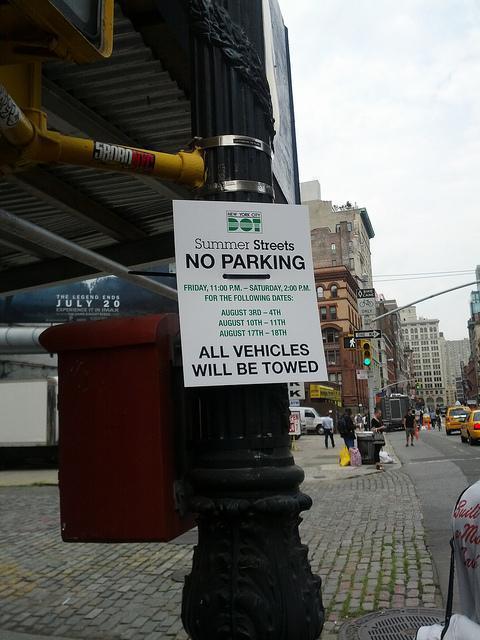What is the green on the bricks on the ground?
Pick the correct solution from the four options below to address the question.
Options: Paint, crayon, apple, moss. Moss. 